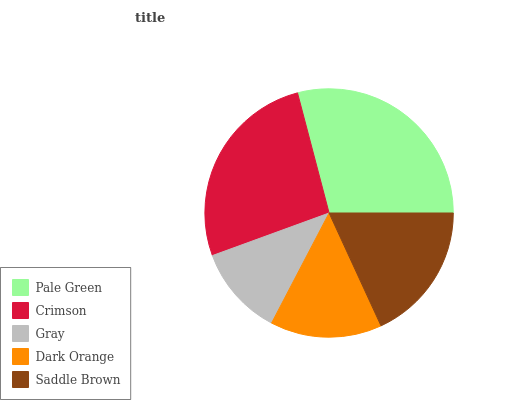Is Gray the minimum?
Answer yes or no. Yes. Is Pale Green the maximum?
Answer yes or no. Yes. Is Crimson the minimum?
Answer yes or no. No. Is Crimson the maximum?
Answer yes or no. No. Is Pale Green greater than Crimson?
Answer yes or no. Yes. Is Crimson less than Pale Green?
Answer yes or no. Yes. Is Crimson greater than Pale Green?
Answer yes or no. No. Is Pale Green less than Crimson?
Answer yes or no. No. Is Saddle Brown the high median?
Answer yes or no. Yes. Is Saddle Brown the low median?
Answer yes or no. Yes. Is Pale Green the high median?
Answer yes or no. No. Is Dark Orange the low median?
Answer yes or no. No. 